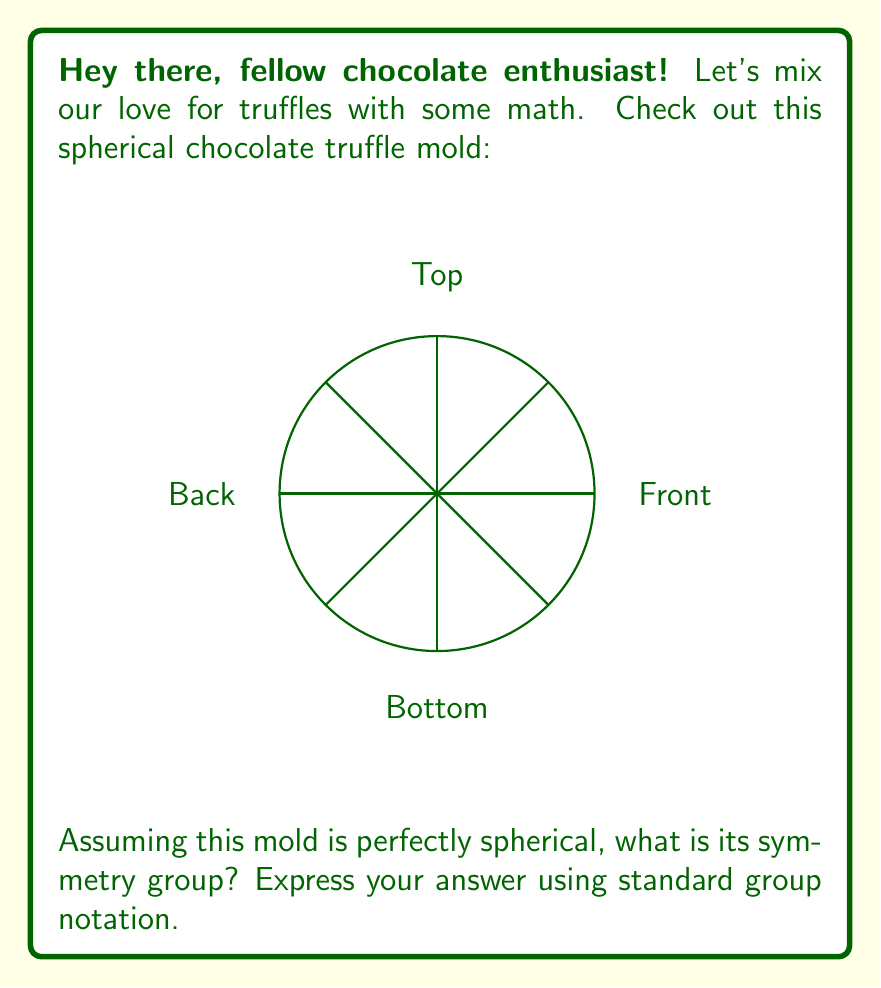Could you help me with this problem? Let's approach this step-by-step:

1) First, we need to identify all the symmetries of a sphere:
   - Rotations around any axis through the center
   - Reflections across any plane through the center

2) These symmetries form the orthogonal group $O(3)$, which includes all distance-preserving transformations of a 3D space that keep the origin fixed.

3) However, we need to consider that this is a mold, not just a mathematical sphere. The mold has a specific orientation with a top, bottom, front, and back.

4) This means we have the following symmetries:
   - Identity: No change
   - Rotation by 180° around the vertical axis
   - Rotation by 180° around the horizontal axis
   - Rotation by 180° around the axis perpendicular to the page
   - Reflection across the vertical plane
   - Reflection across the horizontal plane
   - Reflection across the plane perpendicular to the page
   - Rotation by 90° followed by a reflection (which is equivalent to the previous reflections)

5) These 8 symmetries form a group isomorphic to $D_4$, the dihedral group of order 8.

6) In standard group notation, we can express this as:

   $$D_4 = \langle r, s \mid r^4 = s^2 = 1, srs = r^{-1} \rangle$$

   where $r$ represents a 90° rotation and $s$ represents a reflection.
Answer: $D_4 = \langle r, s \mid r^4 = s^2 = 1, srs = r^{-1} \rangle$ 